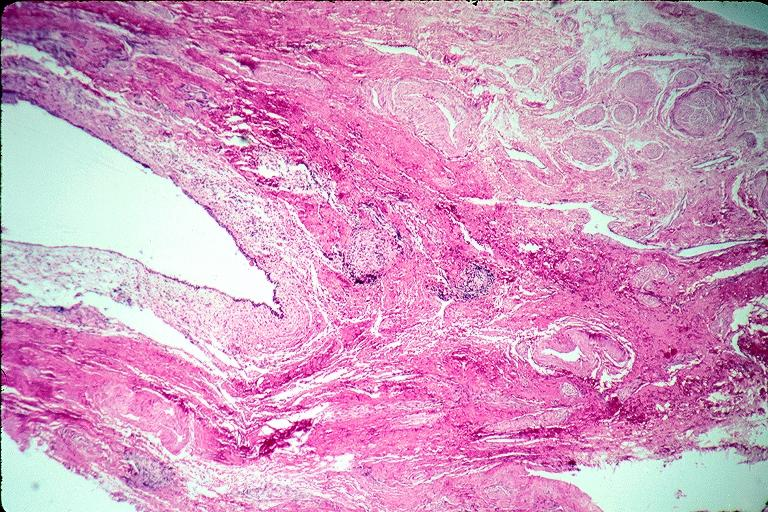s nuclear change present?
Answer the question using a single word or phrase. No 